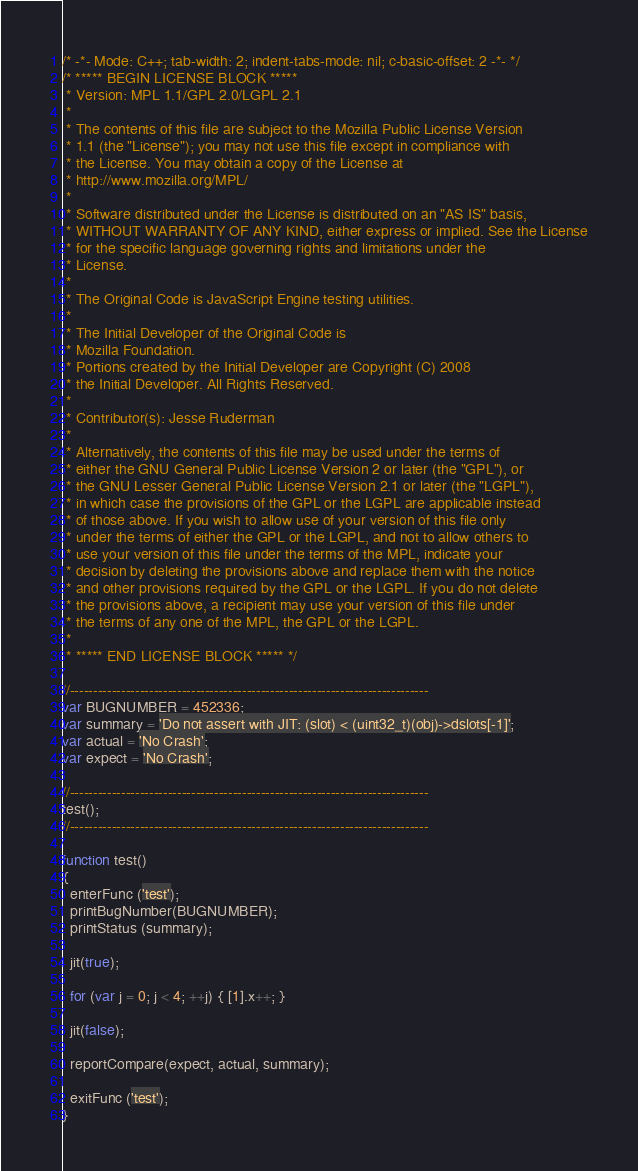<code> <loc_0><loc_0><loc_500><loc_500><_JavaScript_>/* -*- Mode: C++; tab-width: 2; indent-tabs-mode: nil; c-basic-offset: 2 -*- */
/* ***** BEGIN LICENSE BLOCK *****
 * Version: MPL 1.1/GPL 2.0/LGPL 2.1
 *
 * The contents of this file are subject to the Mozilla Public License Version
 * 1.1 (the "License"); you may not use this file except in compliance with
 * the License. You may obtain a copy of the License at
 * http://www.mozilla.org/MPL/
 *
 * Software distributed under the License is distributed on an "AS IS" basis,
 * WITHOUT WARRANTY OF ANY KIND, either express or implied. See the License
 * for the specific language governing rights and limitations under the
 * License.
 *
 * The Original Code is JavaScript Engine testing utilities.
 *
 * The Initial Developer of the Original Code is
 * Mozilla Foundation.
 * Portions created by the Initial Developer are Copyright (C) 2008
 * the Initial Developer. All Rights Reserved.
 *
 * Contributor(s): Jesse Ruderman
 *
 * Alternatively, the contents of this file may be used under the terms of
 * either the GNU General Public License Version 2 or later (the "GPL"), or
 * the GNU Lesser General Public License Version 2.1 or later (the "LGPL"),
 * in which case the provisions of the GPL or the LGPL are applicable instead
 * of those above. If you wish to allow use of your version of this file only
 * under the terms of either the GPL or the LGPL, and not to allow others to
 * use your version of this file under the terms of the MPL, indicate your
 * decision by deleting the provisions above and replace them with the notice
 * and other provisions required by the GPL or the LGPL. If you do not delete
 * the provisions above, a recipient may use your version of this file under
 * the terms of any one of the MPL, the GPL or the LGPL.
 *
 * ***** END LICENSE BLOCK ***** */

//-----------------------------------------------------------------------------
var BUGNUMBER = 452336;
var summary = 'Do not assert with JIT: (slot) < (uint32_t)(obj)->dslots[-1]';
var actual = 'No Crash';
var expect = 'No Crash';

//-----------------------------------------------------------------------------
test();
//-----------------------------------------------------------------------------

function test()
{
  enterFunc ('test');
  printBugNumber(BUGNUMBER);
  printStatus (summary);

  jit(true);

  for (var j = 0; j < 4; ++j) { [1].x++; }

  jit(false);

  reportCompare(expect, actual, summary);

  exitFunc ('test');
}
</code> 